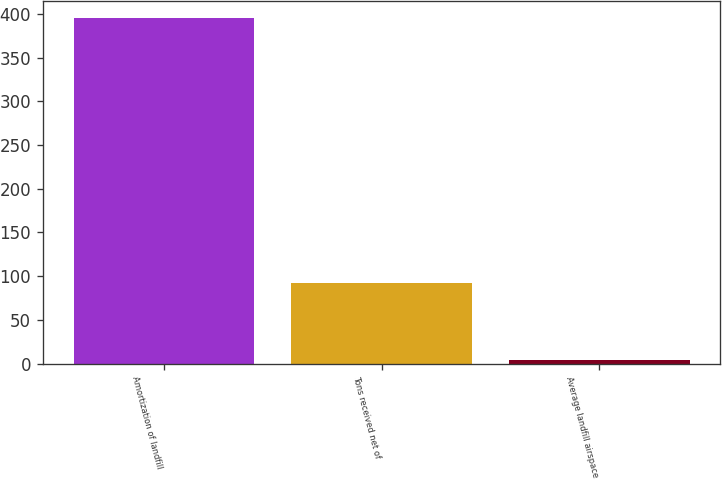Convert chart to OTSL. <chart><loc_0><loc_0><loc_500><loc_500><bar_chart><fcel>Amortization of landfill<fcel>Tons received net of<fcel>Average landfill airspace<nl><fcel>395<fcel>92<fcel>4.3<nl></chart> 